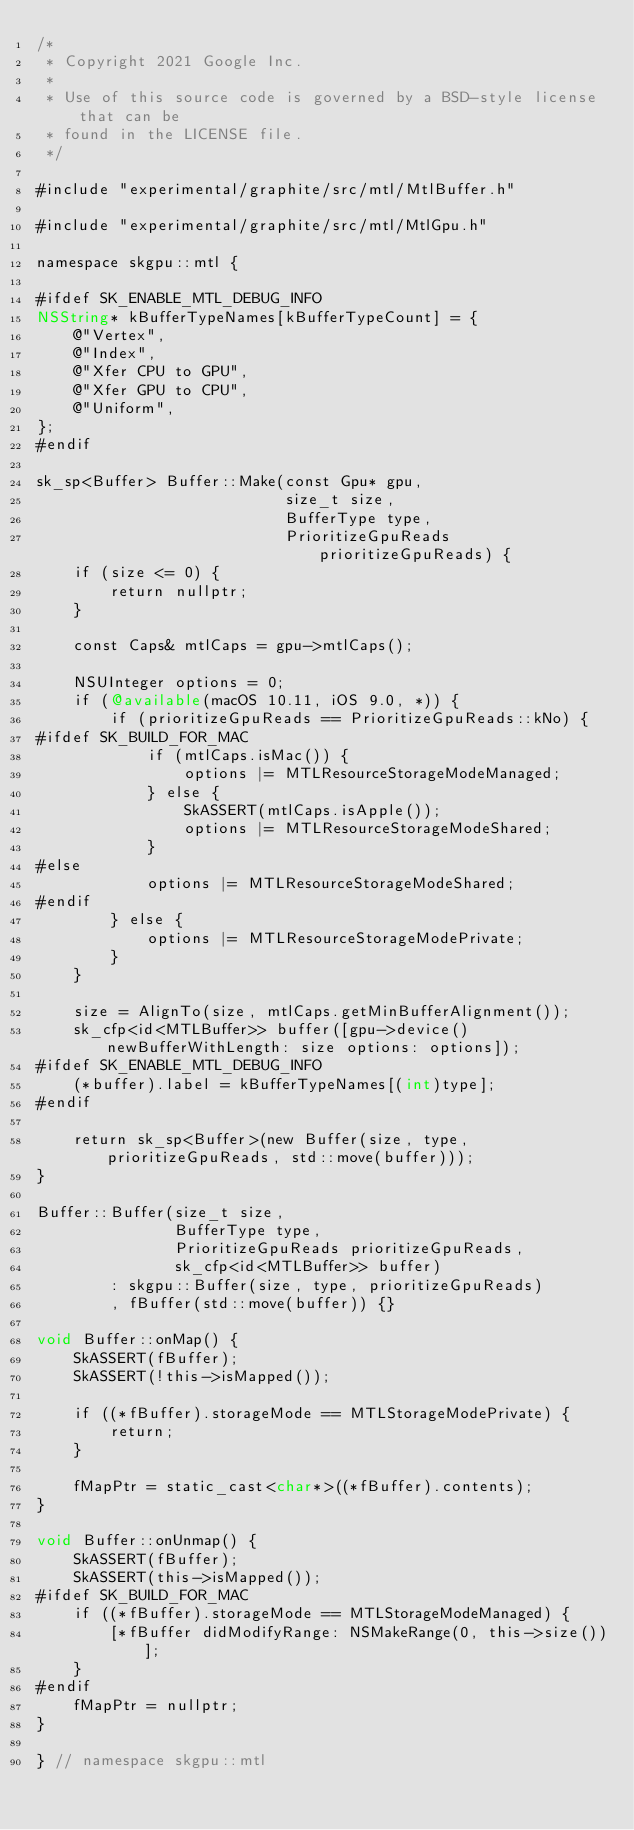Convert code to text. <code><loc_0><loc_0><loc_500><loc_500><_ObjectiveC_>/*
 * Copyright 2021 Google Inc.
 *
 * Use of this source code is governed by a BSD-style license that can be
 * found in the LICENSE file.
 */

#include "experimental/graphite/src/mtl/MtlBuffer.h"

#include "experimental/graphite/src/mtl/MtlGpu.h"

namespace skgpu::mtl {

#ifdef SK_ENABLE_MTL_DEBUG_INFO
NSString* kBufferTypeNames[kBufferTypeCount] = {
    @"Vertex",
    @"Index",
    @"Xfer CPU to GPU",
    @"Xfer GPU to CPU",
    @"Uniform",
};
#endif

sk_sp<Buffer> Buffer::Make(const Gpu* gpu,
                           size_t size,
                           BufferType type,
                           PrioritizeGpuReads prioritizeGpuReads) {
    if (size <= 0) {
        return nullptr;
    }

    const Caps& mtlCaps = gpu->mtlCaps();

    NSUInteger options = 0;
    if (@available(macOS 10.11, iOS 9.0, *)) {
        if (prioritizeGpuReads == PrioritizeGpuReads::kNo) {
#ifdef SK_BUILD_FOR_MAC
            if (mtlCaps.isMac()) {
                options |= MTLResourceStorageModeManaged;
            } else {
                SkASSERT(mtlCaps.isApple());
                options |= MTLResourceStorageModeShared;
            }
#else
            options |= MTLResourceStorageModeShared;
#endif
        } else {
            options |= MTLResourceStorageModePrivate;
        }
    }

    size = AlignTo(size, mtlCaps.getMinBufferAlignment());
    sk_cfp<id<MTLBuffer>> buffer([gpu->device() newBufferWithLength: size options: options]);
#ifdef SK_ENABLE_MTL_DEBUG_INFO
    (*buffer).label = kBufferTypeNames[(int)type];
#endif

    return sk_sp<Buffer>(new Buffer(size, type, prioritizeGpuReads, std::move(buffer)));
}

Buffer::Buffer(size_t size,
               BufferType type,
               PrioritizeGpuReads prioritizeGpuReads,
               sk_cfp<id<MTLBuffer>> buffer)
        : skgpu::Buffer(size, type, prioritizeGpuReads)
        , fBuffer(std::move(buffer)) {}

void Buffer::onMap() {
    SkASSERT(fBuffer);
    SkASSERT(!this->isMapped());

    if ((*fBuffer).storageMode == MTLStorageModePrivate) {
        return;
    }

    fMapPtr = static_cast<char*>((*fBuffer).contents);
}

void Buffer::onUnmap() {
    SkASSERT(fBuffer);
    SkASSERT(this->isMapped());
#ifdef SK_BUILD_FOR_MAC
    if ((*fBuffer).storageMode == MTLStorageModeManaged) {
        [*fBuffer didModifyRange: NSMakeRange(0, this->size())];
    }
#endif
    fMapPtr = nullptr;
}

} // namespace skgpu::mtl

</code> 